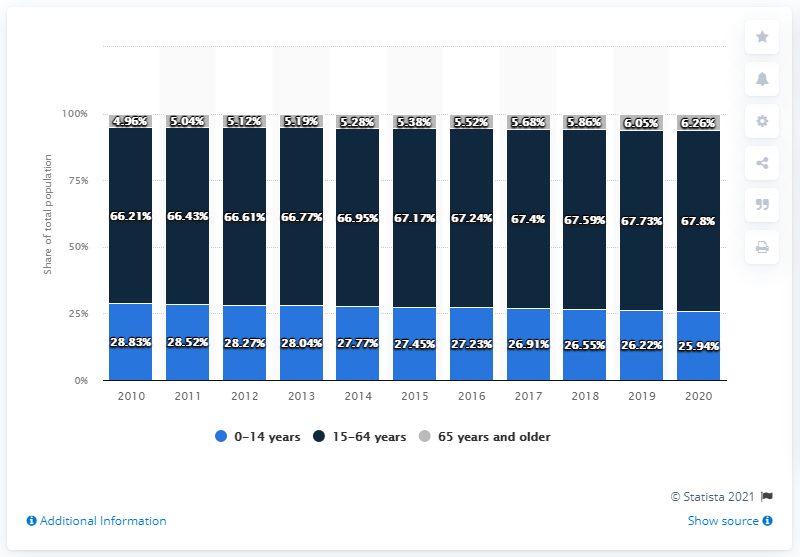Draw attention to some important aspects in this diagram. The population of 15-64 year olds in 2020 was 0.07% less than in 2019. In 2010, the population aged 65 years and older accounted for 4.96% of the total population. 